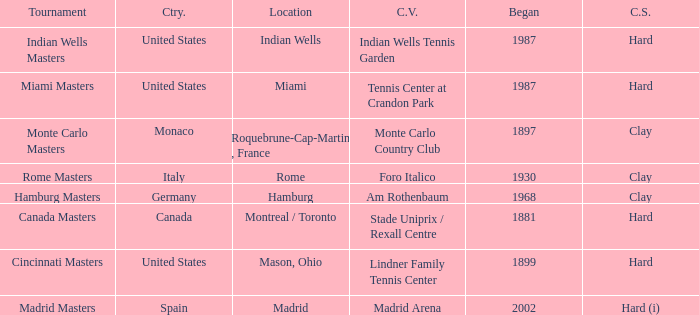How many tournaments have their current venue as the Lindner Family Tennis Center? 1.0. 